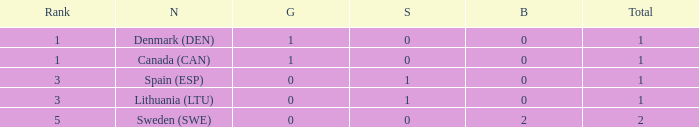What is the number of gold medals for Lithuania (ltu), when the total is more than 1? None. 